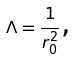<formula> <loc_0><loc_0><loc_500><loc_500>\Lambda = \frac { 1 } { r _ { 0 } ^ { 2 } } \text {, }</formula> 